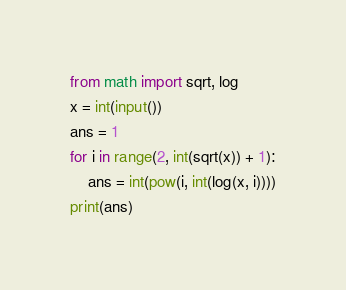Convert code to text. <code><loc_0><loc_0><loc_500><loc_500><_Python_>from math import sqrt, log
x = int(input())
ans = 1
for i in range(2, int(sqrt(x)) + 1):
    ans = int(pow(i, int(log(x, i))))
print(ans)
</code> 